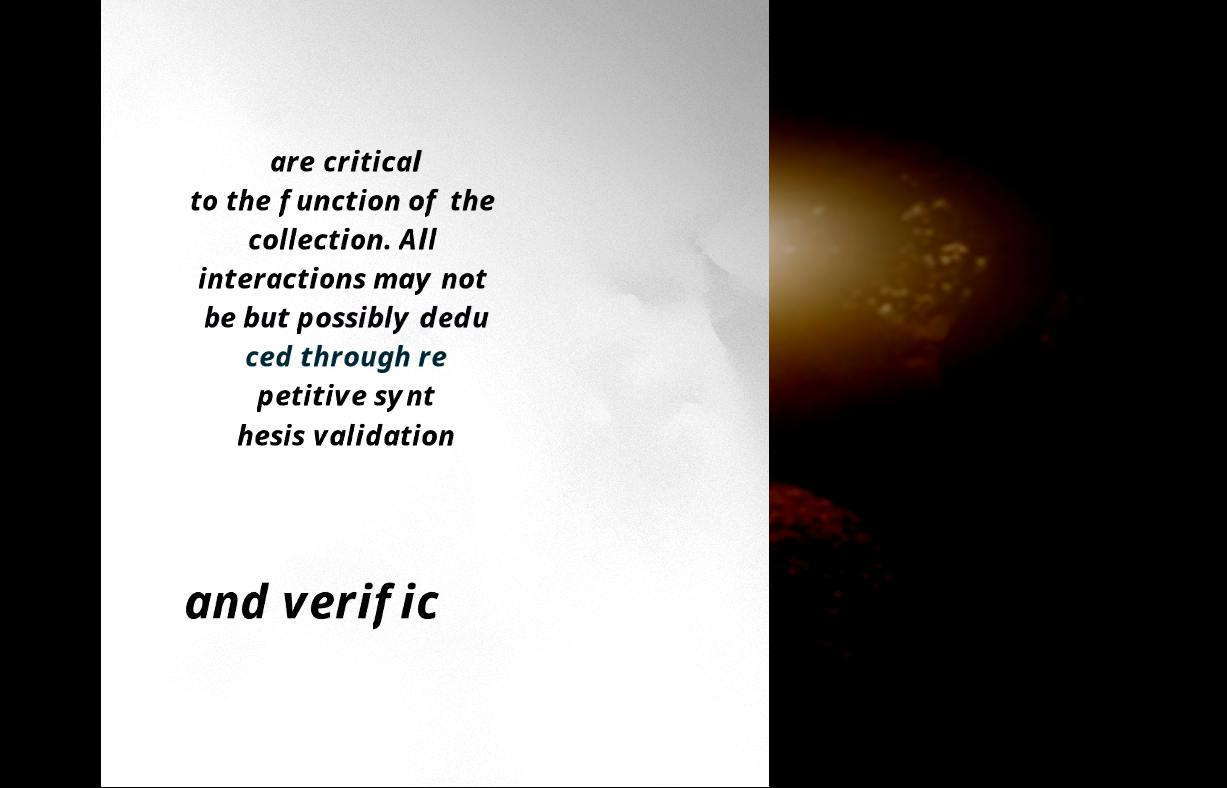Could you extract and type out the text from this image? are critical to the function of the collection. All interactions may not be but possibly dedu ced through re petitive synt hesis validation and verific 